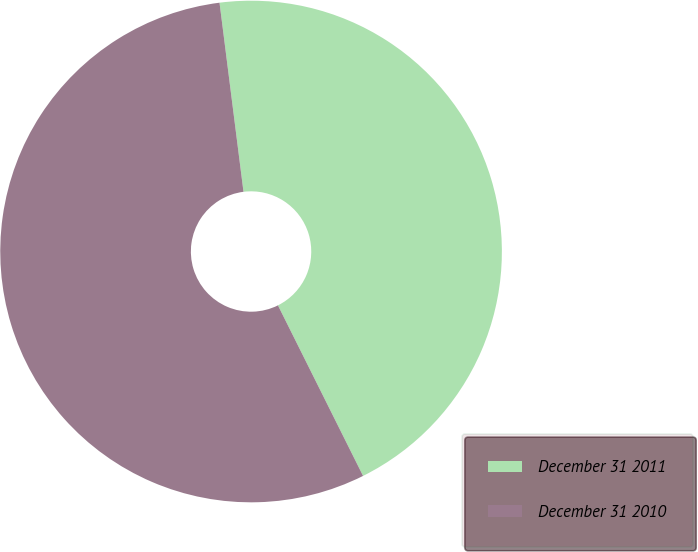<chart> <loc_0><loc_0><loc_500><loc_500><pie_chart><fcel>December 31 2011<fcel>December 31 2010<nl><fcel>44.64%<fcel>55.36%<nl></chart> 